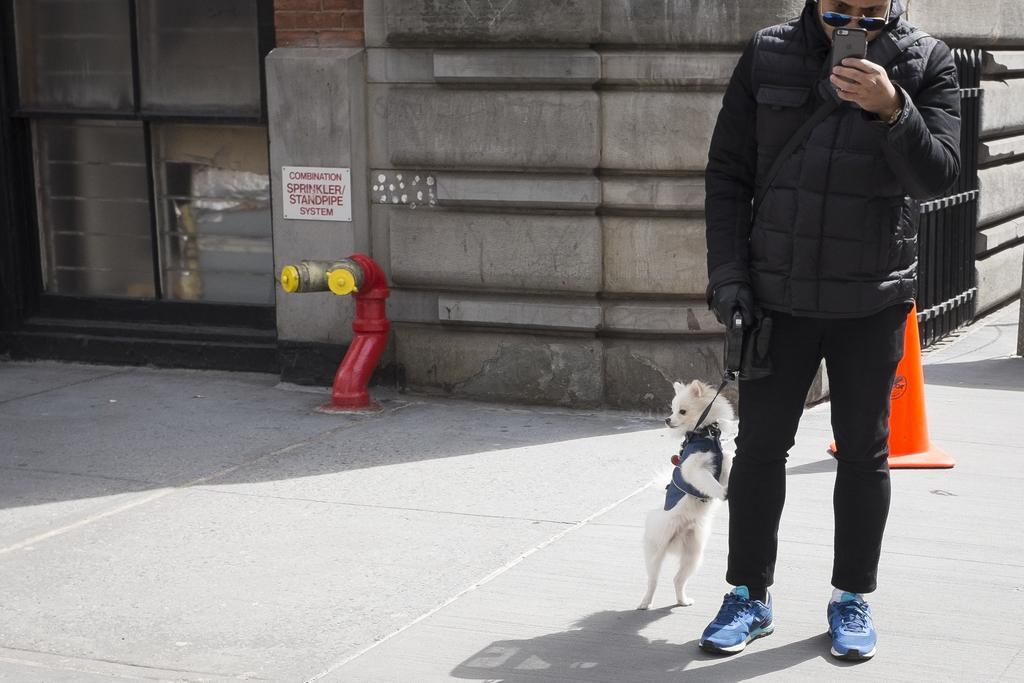Could you give a brief overview of what you see in this image? There is a building. A man is standing here. He is holding the dog with the help of a chain. He is wearing a black jacket. In his hand there is a mobile phone. He is wearing sunglasses. He is looking at his phone. There is a traffic cone behind him. He is wearing blue shoes. There is a sign board. It is written combination sprinkler / standpipe system. This is the sprinkler. The man is wearing a glove. He is wearing a watch in his hand. The dog is in a standing position. 